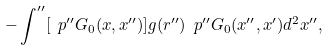<formula> <loc_0><loc_0><loc_500><loc_500>- \int ^ { \prime \prime } [ \ p ^ { \prime \prime } G _ { 0 } ( x , x ^ { \prime \prime } ) ] g ( r ^ { \prime \prime } ) \ p ^ { \prime \prime } G _ { 0 } ( x ^ { \prime \prime } , x ^ { \prime } ) d ^ { 2 } x ^ { \prime \prime } ,</formula> 